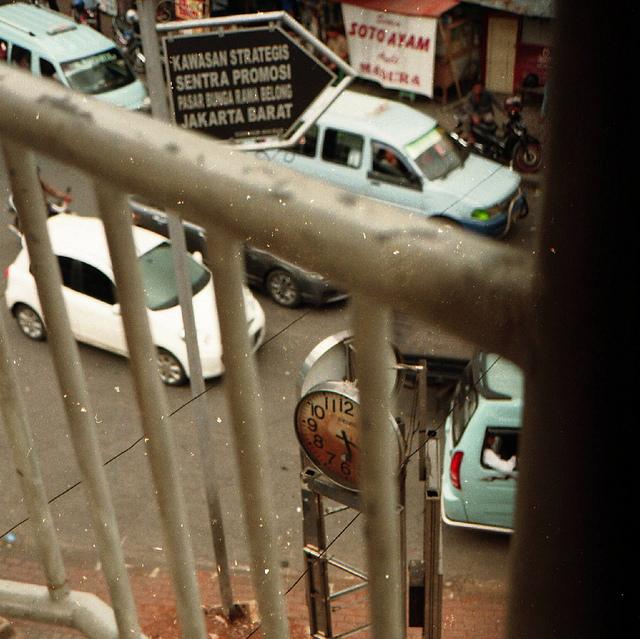What time is on the clock?
Quick response, please. 5:15. Is this in the USA?
Give a very brief answer. No. Is this a view from the second floor?
Concise answer only. Yes. 